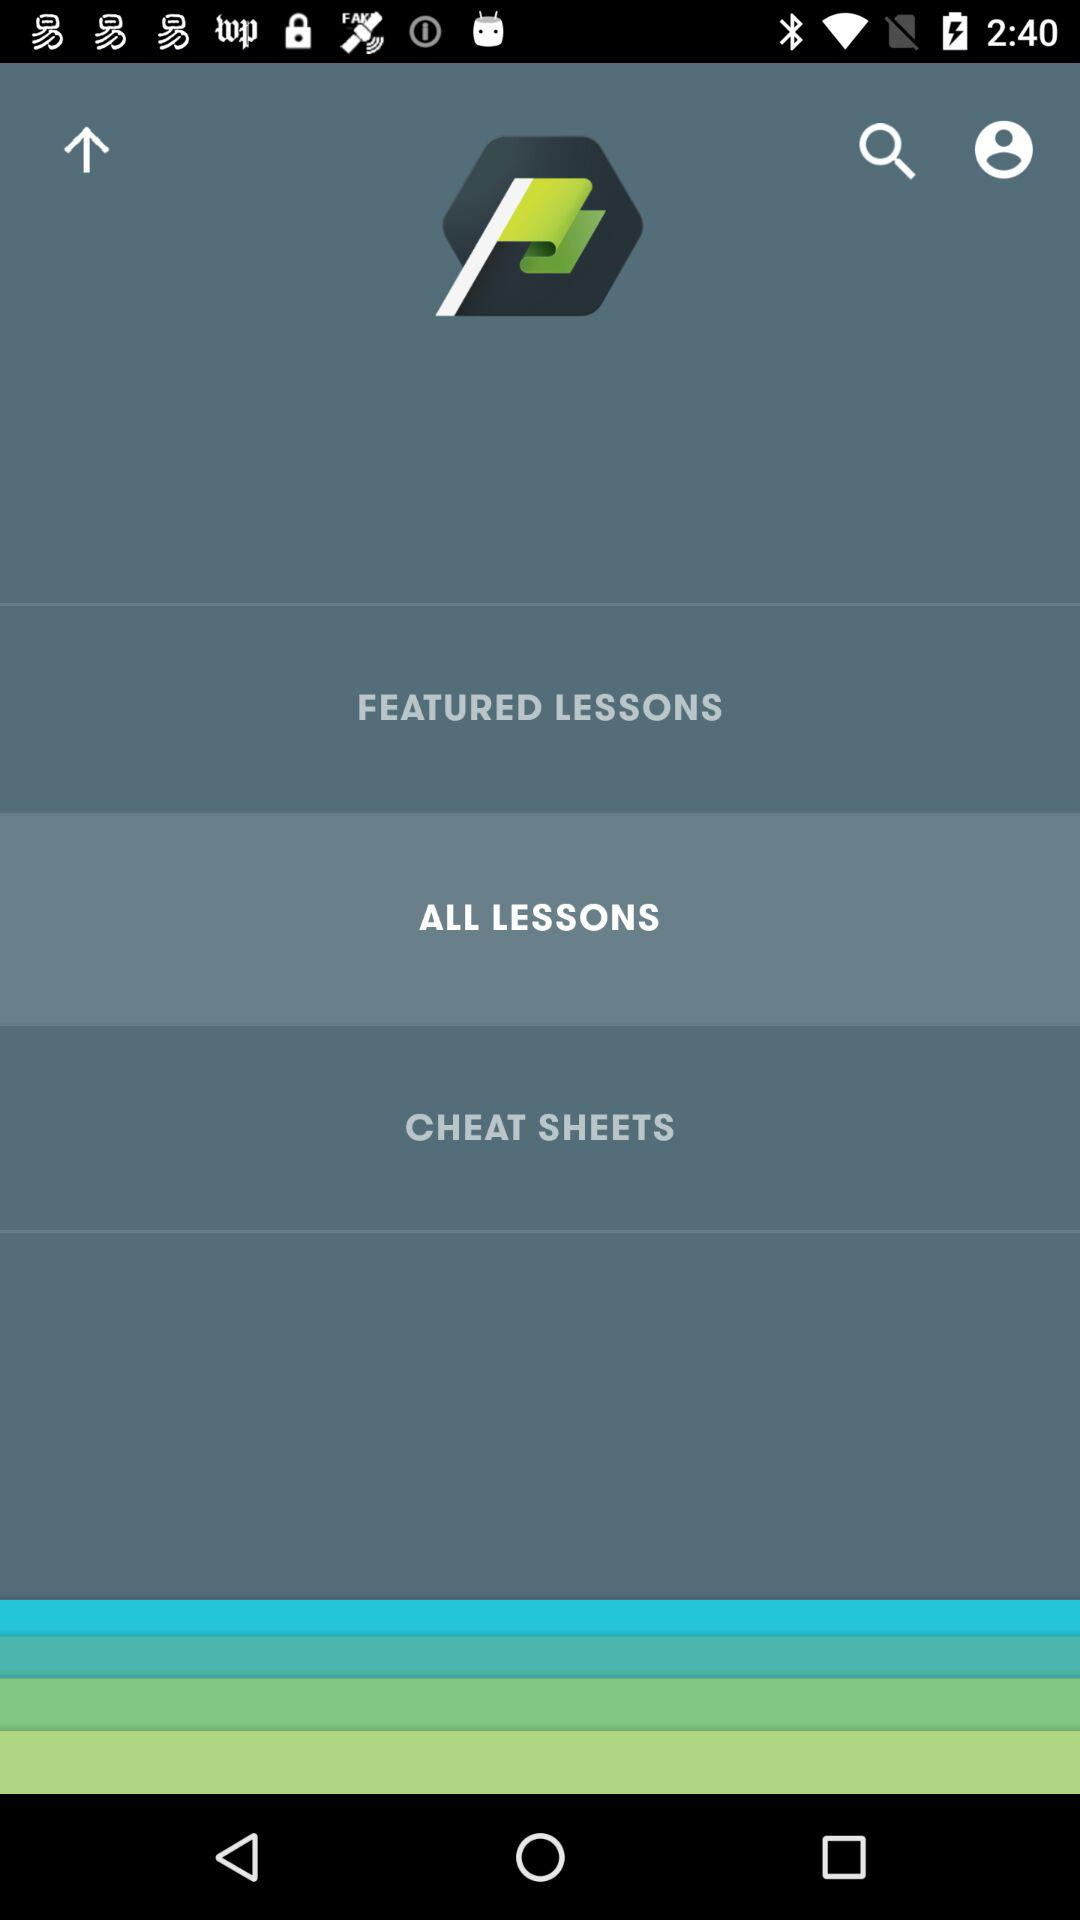Which option has been selected? The selected option is "ALL LESSONS". 